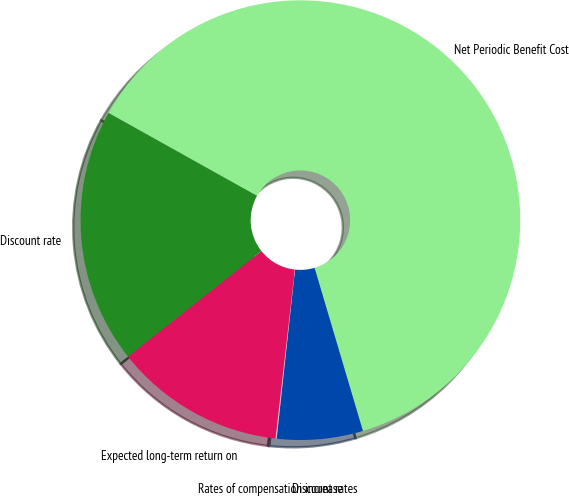Convert chart to OTSL. <chart><loc_0><loc_0><loc_500><loc_500><pie_chart><fcel>Net Periodic Benefit Cost<fcel>Discount rates<fcel>Rates of compensation increase<fcel>Expected long-term return on<fcel>Discount rate<nl><fcel>62.3%<fcel>6.31%<fcel>0.09%<fcel>12.53%<fcel>18.76%<nl></chart> 